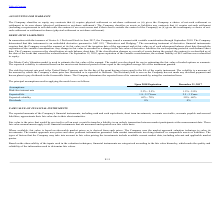According to Finjan Holding's financial document, What is the expected life upon 2018 expiration? According to the financial document, 1.8 - 2.2 Years. The relevant text states: "Expected life 1.8 - 2.2 Years 2.5 - 3 Years..." Also, What is the expected life as at December 31, 2017? According to the financial document, 2.5 - 3 Years. The relevant text states: "Expected life 1.8 - 2.2 Years 2.5 - 3 Years..." Also, What is the percentage dividends of the derivative liabilities? According to the financial document, 0%. The relevant text states: "ons: Risk-free interest rate 2.3% - 2.5% 1.5% - 2.0%..." Also, can you calculate: What is the average expected life upon 2018 expiration? To answer this question, I need to perform calculations using the financial data. The calculation is: (1.8 + 2.2)/2 , which equals 2. This is based on the information: "Expected life 1.8 - 2.2 Years 2.5 - 3 Years Expected life 1.8 - 2.2 Years 2.5 - 3 Years..." The key data points involved are: 1.8, 2.2. Also, can you calculate: What is the average expected life as at December 31, 2017? To answer this question, I need to perform calculations using the financial data. The calculation is: (2.5 + 3)/2 , which equals 2.75. This is based on the information: "Assumptions: Risk-free interest rate 2.3% - 2.5% 1.5% - 2.0% Assumptions: Risk-free interest rate 2.3% - 2.5% 1.5% - 2.0%..." The key data points involved are: 2.5, 3. Also, can you calculate: What is the average expected volatility of derivative liabilities due on December 31, 2017? To answer this question, I need to perform calculations using the financial data. The calculation is: ( 50 + 60)/2 , which equals 55 (percentage). This is based on the information: "Expected volatility 65% - 70% 50% - 60% Expected volatility 65% - 70% 50% - 60%..." The key data points involved are: 50, 60. 